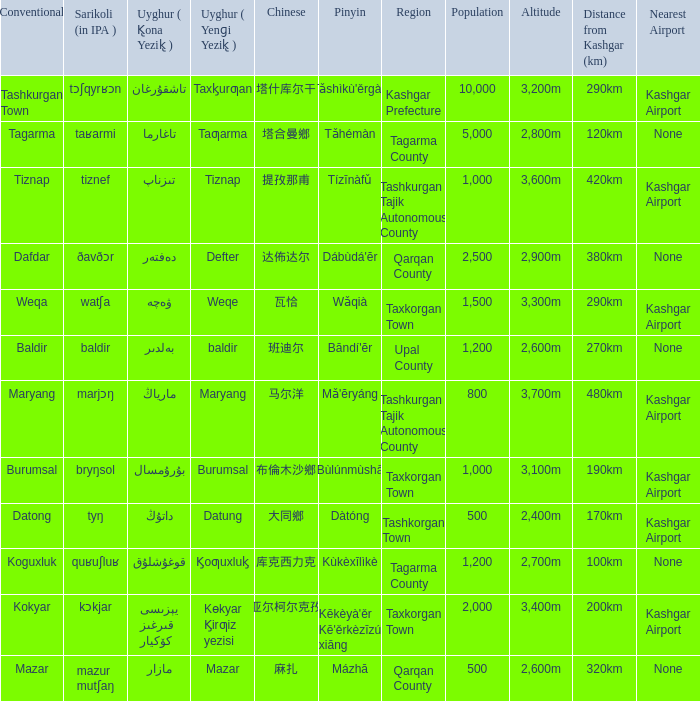Name the pinyin for تىزناپ Tízīnàfǔ. 